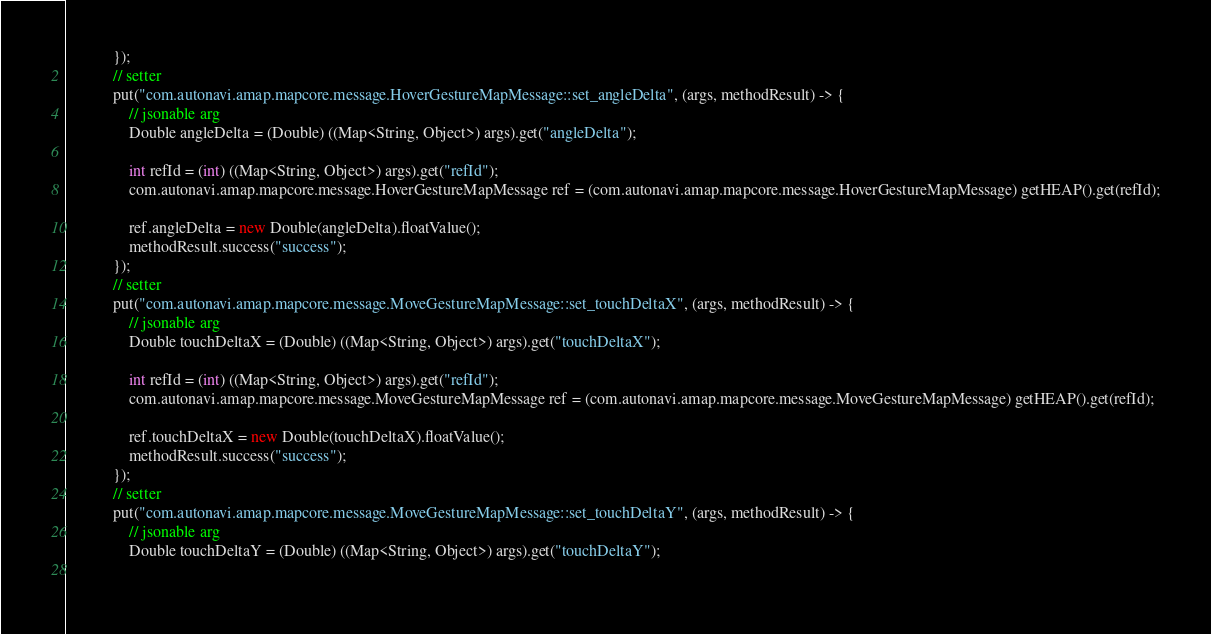Convert code to text. <code><loc_0><loc_0><loc_500><loc_500><_Java_>            });
            // setter
            put("com.autonavi.amap.mapcore.message.HoverGestureMapMessage::set_angleDelta", (args, methodResult) -> {
                // jsonable arg
                Double angleDelta = (Double) ((Map<String, Object>) args).get("angleDelta");
            
                int refId = (int) ((Map<String, Object>) args).get("refId");
                com.autonavi.amap.mapcore.message.HoverGestureMapMessage ref = (com.autonavi.amap.mapcore.message.HoverGestureMapMessage) getHEAP().get(refId);
            
                ref.angleDelta = new Double(angleDelta).floatValue();
                methodResult.success("success");
            });
            // setter
            put("com.autonavi.amap.mapcore.message.MoveGestureMapMessage::set_touchDeltaX", (args, methodResult) -> {
                // jsonable arg
                Double touchDeltaX = (Double) ((Map<String, Object>) args).get("touchDeltaX");
            
                int refId = (int) ((Map<String, Object>) args).get("refId");
                com.autonavi.amap.mapcore.message.MoveGestureMapMessage ref = (com.autonavi.amap.mapcore.message.MoveGestureMapMessage) getHEAP().get(refId);
            
                ref.touchDeltaX = new Double(touchDeltaX).floatValue();
                methodResult.success("success");
            });
            // setter
            put("com.autonavi.amap.mapcore.message.MoveGestureMapMessage::set_touchDeltaY", (args, methodResult) -> {
                // jsonable arg
                Double touchDeltaY = (Double) ((Map<String, Object>) args).get("touchDeltaY");
            </code> 